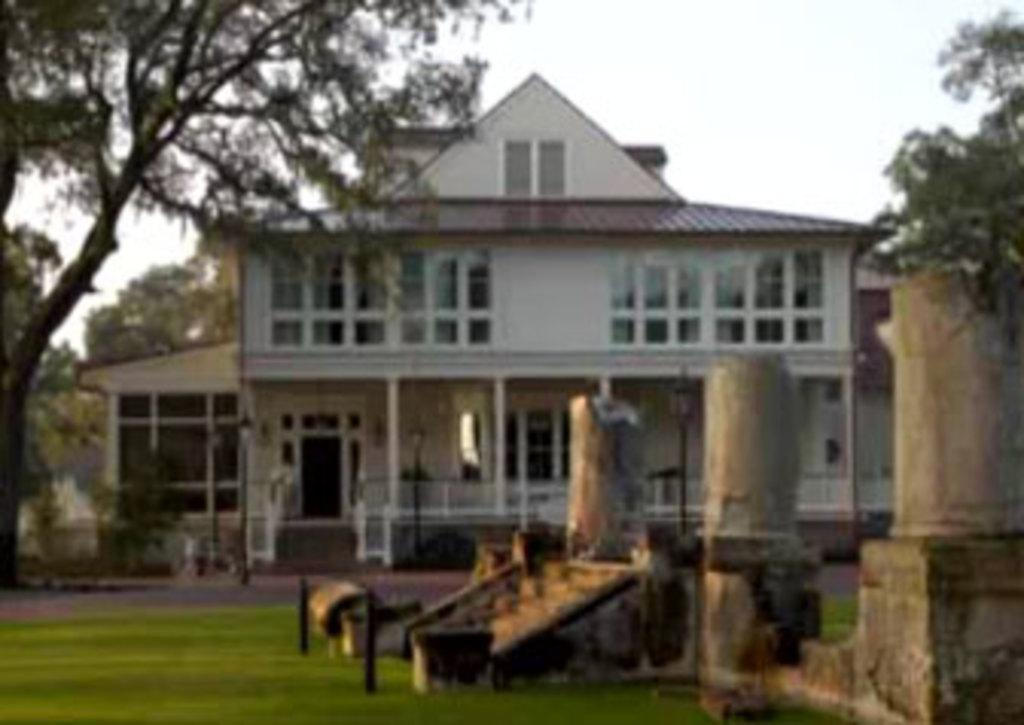What type of surface is at the bottom of the image? There is grass on the ground at the bottom of the image. What structures can be seen in the image? There are poles, steps, and pillars in the image. What type of building is visible in the background? There is a building in the background of the image. What architectural features can be seen in the background? There are windows, doors, and a fence in the background of the image. What is visible in the sky in the image? The sky is visible in the background of the image. What type of wood is the carpenter using to act out a sorting scene in the image? There is no carpenter or sorting scene present in the image. 